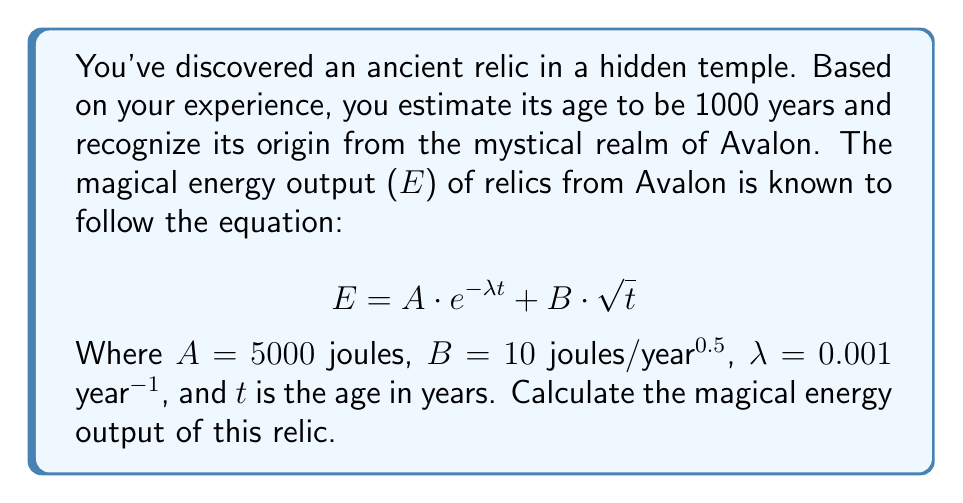Can you answer this question? To solve this problem, we'll follow these steps:

1. Identify the given values:
   $A = 5000$ joules
   $B = 10$ joules/year^0.5
   $\lambda = 0.001$ year^-1
   $t = 1000$ years

2. Substitute these values into the equation:
   $$ E = 5000 \cdot e^{-0.001 \cdot 1000} + 10 \cdot \sqrt{1000} $$

3. Calculate the exponential term:
   $e^{-0.001 \cdot 1000} = e^{-1} \approx 0.3679$

4. Calculate the square root term:
   $\sqrt{1000} \approx 31.6228$

5. Multiply the results with their respective coefficients:
   $5000 \cdot 0.3679 \approx 1839.5$
   $10 \cdot 31.6228 \approx 316.228$

6. Sum the two parts:
   $E = 1839.5 + 316.228 \approx 2155.728$ joules

Therefore, the magical energy output of the ancient relic is approximately 2155.728 joules.
Answer: 2155.728 joules 